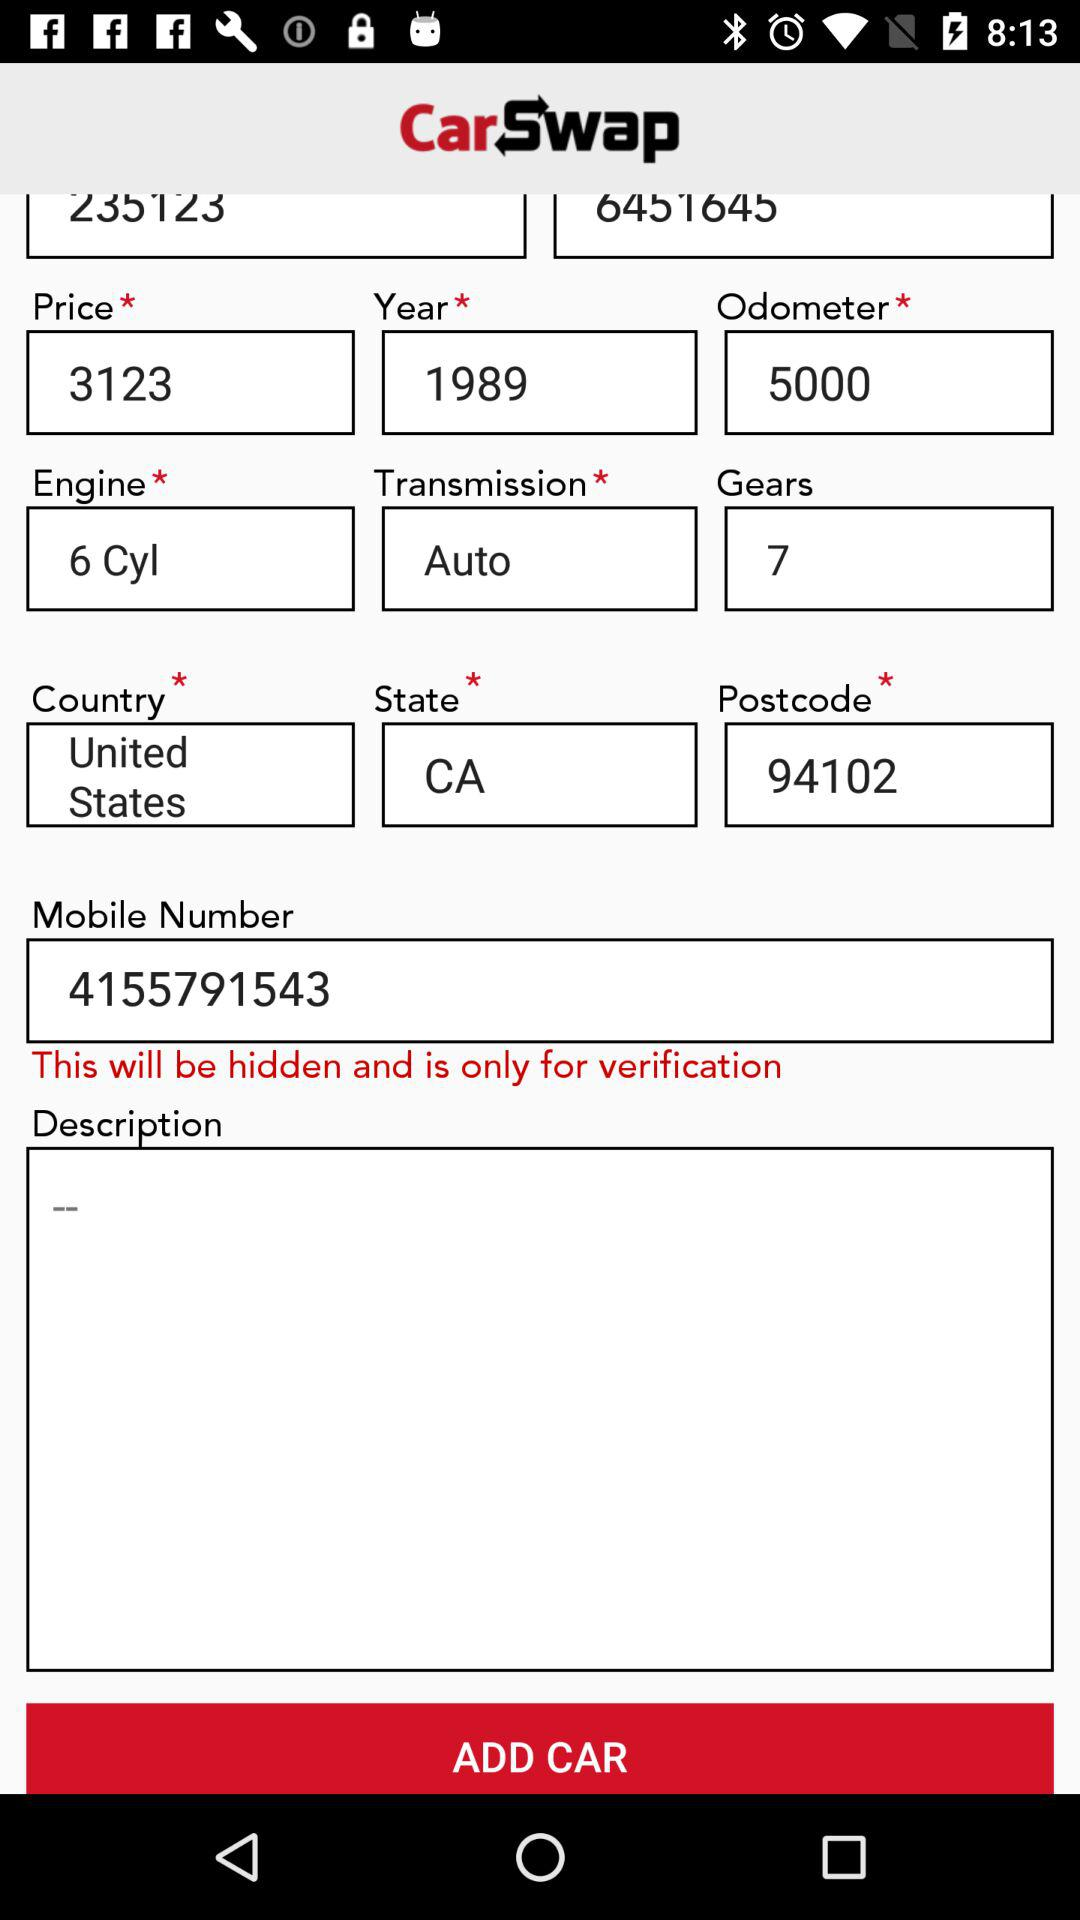What is the mobile number? The mobile number is 4155791543. 